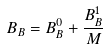Convert formula to latex. <formula><loc_0><loc_0><loc_500><loc_500>B _ { B } = B ^ { 0 } _ { B } + \frac { B ^ { 1 } _ { B } } { M }</formula> 